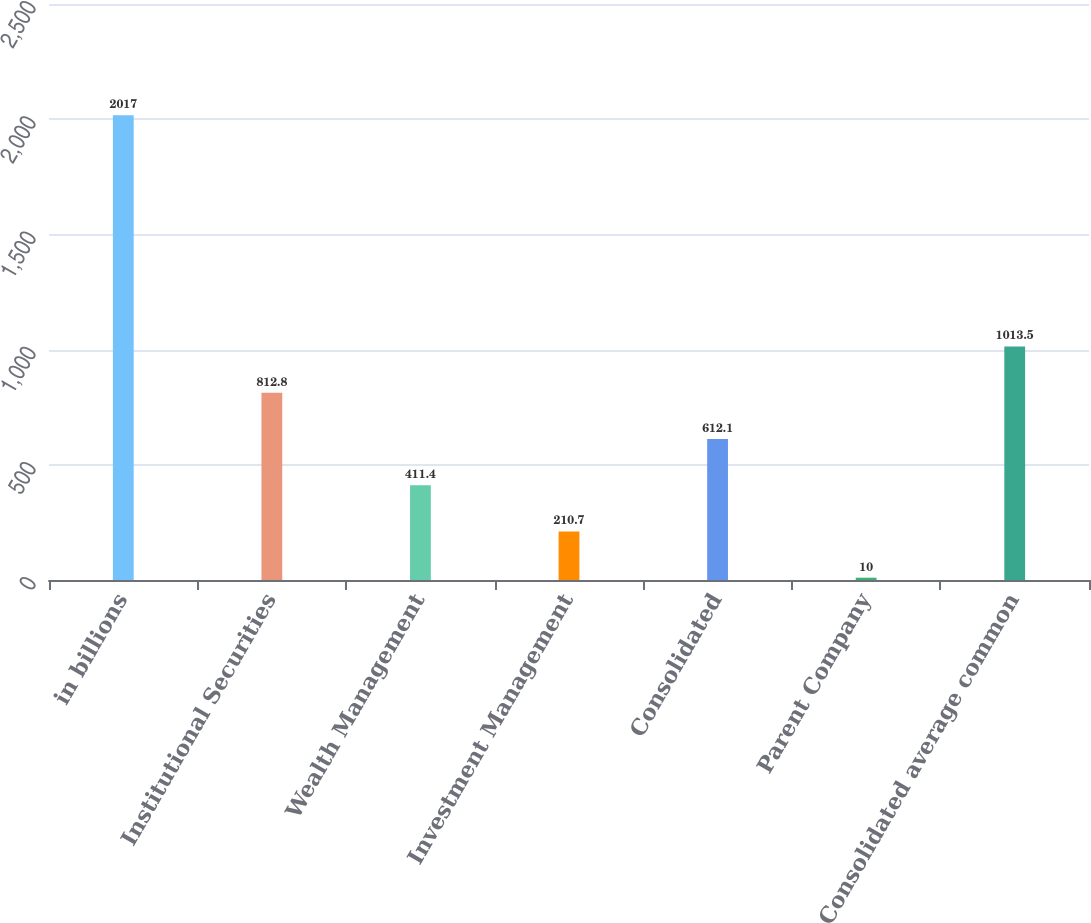<chart> <loc_0><loc_0><loc_500><loc_500><bar_chart><fcel>in billions<fcel>Institutional Securities<fcel>Wealth Management<fcel>Investment Management<fcel>Consolidated<fcel>Parent Company<fcel>Consolidated average common<nl><fcel>2017<fcel>812.8<fcel>411.4<fcel>210.7<fcel>612.1<fcel>10<fcel>1013.5<nl></chart> 